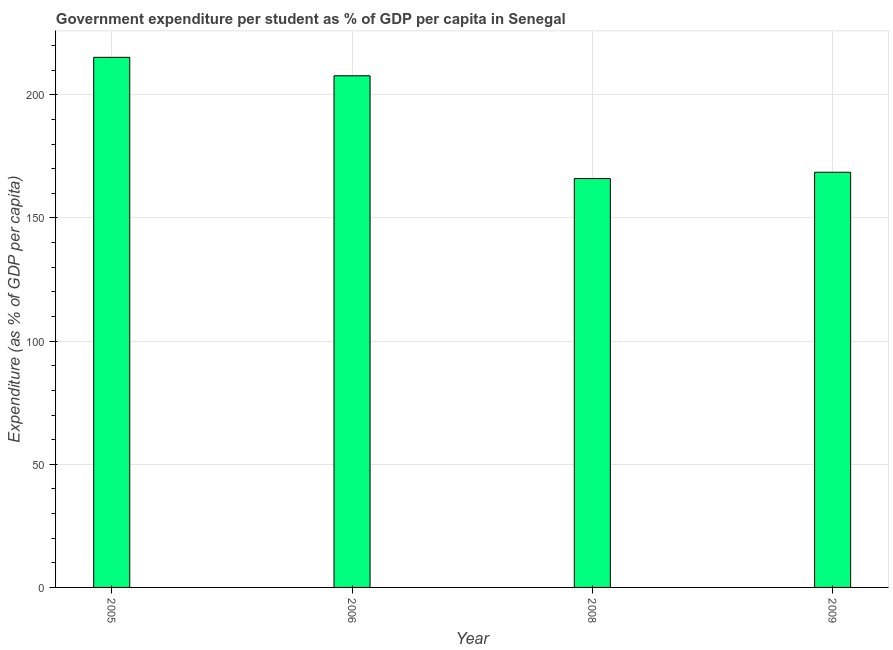Does the graph contain any zero values?
Offer a terse response. No. Does the graph contain grids?
Give a very brief answer. Yes. What is the title of the graph?
Make the answer very short. Government expenditure per student as % of GDP per capita in Senegal. What is the label or title of the Y-axis?
Your answer should be very brief. Expenditure (as % of GDP per capita). What is the government expenditure per student in 2009?
Your answer should be compact. 168.54. Across all years, what is the maximum government expenditure per student?
Your answer should be very brief. 215.21. Across all years, what is the minimum government expenditure per student?
Keep it short and to the point. 166. In which year was the government expenditure per student minimum?
Make the answer very short. 2008. What is the sum of the government expenditure per student?
Provide a short and direct response. 757.46. What is the difference between the government expenditure per student in 2006 and 2008?
Keep it short and to the point. 41.72. What is the average government expenditure per student per year?
Give a very brief answer. 189.37. What is the median government expenditure per student?
Your response must be concise. 188.13. What is the ratio of the government expenditure per student in 2006 to that in 2009?
Provide a short and direct response. 1.23. Is the difference between the government expenditure per student in 2006 and 2008 greater than the difference between any two years?
Offer a very short reply. No. What is the difference between the highest and the second highest government expenditure per student?
Offer a very short reply. 7.5. Is the sum of the government expenditure per student in 2005 and 2009 greater than the maximum government expenditure per student across all years?
Ensure brevity in your answer.  Yes. What is the difference between the highest and the lowest government expenditure per student?
Keep it short and to the point. 49.21. In how many years, is the government expenditure per student greater than the average government expenditure per student taken over all years?
Ensure brevity in your answer.  2. How many bars are there?
Keep it short and to the point. 4. Are all the bars in the graph horizontal?
Offer a terse response. No. Are the values on the major ticks of Y-axis written in scientific E-notation?
Provide a short and direct response. No. What is the Expenditure (as % of GDP per capita) of 2005?
Your response must be concise. 215.21. What is the Expenditure (as % of GDP per capita) in 2006?
Make the answer very short. 207.71. What is the Expenditure (as % of GDP per capita) in 2008?
Keep it short and to the point. 166. What is the Expenditure (as % of GDP per capita) in 2009?
Offer a terse response. 168.54. What is the difference between the Expenditure (as % of GDP per capita) in 2005 and 2006?
Offer a terse response. 7.5. What is the difference between the Expenditure (as % of GDP per capita) in 2005 and 2008?
Make the answer very short. 49.21. What is the difference between the Expenditure (as % of GDP per capita) in 2005 and 2009?
Ensure brevity in your answer.  46.67. What is the difference between the Expenditure (as % of GDP per capita) in 2006 and 2008?
Provide a short and direct response. 41.72. What is the difference between the Expenditure (as % of GDP per capita) in 2006 and 2009?
Give a very brief answer. 39.17. What is the difference between the Expenditure (as % of GDP per capita) in 2008 and 2009?
Keep it short and to the point. -2.55. What is the ratio of the Expenditure (as % of GDP per capita) in 2005 to that in 2006?
Offer a very short reply. 1.04. What is the ratio of the Expenditure (as % of GDP per capita) in 2005 to that in 2008?
Offer a terse response. 1.3. What is the ratio of the Expenditure (as % of GDP per capita) in 2005 to that in 2009?
Give a very brief answer. 1.28. What is the ratio of the Expenditure (as % of GDP per capita) in 2006 to that in 2008?
Offer a very short reply. 1.25. What is the ratio of the Expenditure (as % of GDP per capita) in 2006 to that in 2009?
Your answer should be compact. 1.23. 